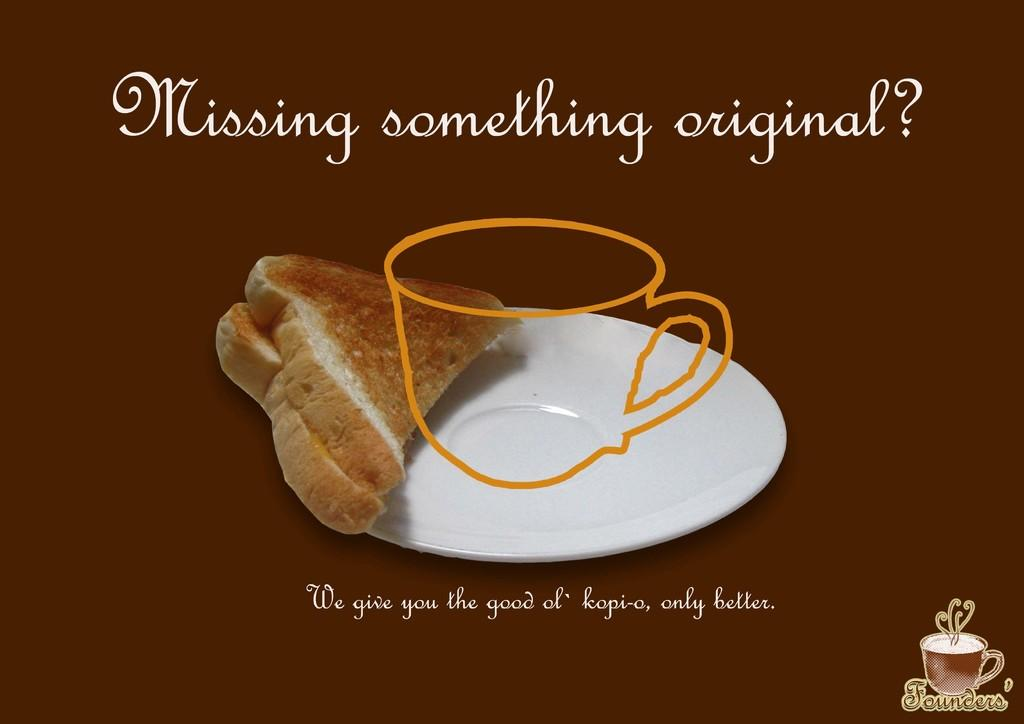What is featured on the poster in the image? There is a poster in the image that contains a saucer with food. What else can be seen on the poster besides the saucer with food? There is text on the poster. What color is the badge on the saucer in the image? There is no badge present on the saucer in the image. How much does the answer weigh in the image? There is no answer present in the image, and therefore its weight cannot be determined. 